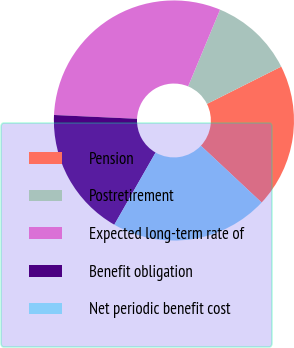Convert chart. <chart><loc_0><loc_0><loc_500><loc_500><pie_chart><fcel>Pension<fcel>Postretirement<fcel>Expected long-term rate of<fcel>Benefit obligation<fcel>Net periodic benefit cost<nl><fcel>19.38%<fcel>11.31%<fcel>30.55%<fcel>17.46%<fcel>21.3%<nl></chart> 